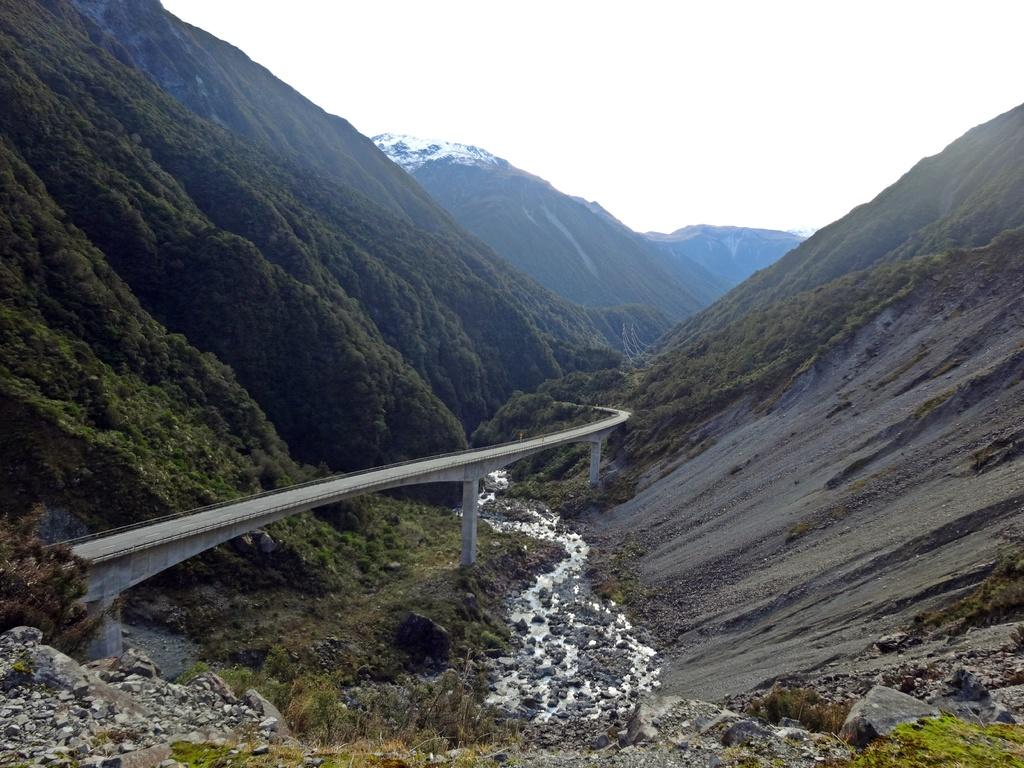What can be seen in the sky in the image? The sky is visible in the image. What type of geographical feature is present in the image? There are hills in the image. What structure can be seen in the image? There is a bridge in the image. What architectural elements are present in the image? Pillars are present in the image. What type of natural feature is visible in the image? Rocks are visible in the image. What type of water is present in the image? There is flowing water in the image. What type of vegetation is present in the image? Plants are present in the image. What type of ground cover is visible in the image? Grass is visible in the image. What type of smile is present on the rocks in the image? There is no smile present on the rocks in the image, as rocks are inanimate objects and do not have facial expressions. 